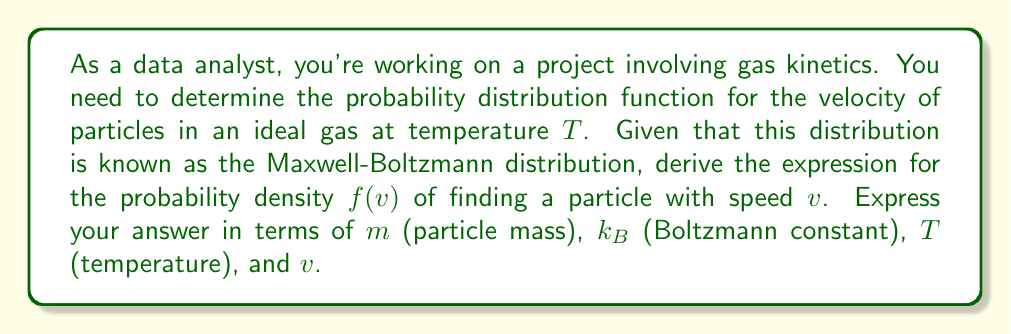Teach me how to tackle this problem. To derive the Maxwell-Boltzmann distribution, we'll follow these steps:

1) In three dimensions, the velocity distribution is given by:

   $$f(v_x, v_y, v_z) = A \exp\left(-\frac{m(v_x^2 + v_y^2 + v_z^2)}{2k_BT}\right)$$

   where $A$ is a normalization constant.

2) We want to find $f(v)$, where $v = \sqrt{v_x^2 + v_y^2 + v_z^2}$. To do this, we need to integrate over all directions in spherical coordinates.

3) In spherical coordinates, $v_x^2 + v_y^2 + v_z^2 = v^2$, and the volume element is $4\pi v^2 dv$.

4) Therefore, $f(v)$ is given by:

   $$f(v) = 4\pi v^2 \cdot A \exp\left(-\frac{mv^2}{2k_BT}\right)$$

5) To find $A$, we use the normalization condition:

   $$\int_0^\infty f(v) dv = 1$$

6) Solving this integral equation gives:

   $$A = \left(\frac{m}{2\pi k_BT}\right)^{3/2}$$

7) Substituting this back into our expression for $f(v)$:

   $$f(v) = 4\pi v^2 \cdot \left(\frac{m}{2\pi k_BT}\right)^{3/2} \exp\left(-\frac{mv^2}{2k_BT}\right)$$

8) Simplifying:

   $$f(v) = 4\pi \left(\frac{m}{2\pi k_BT}\right)^{3/2} v^2 \exp\left(-\frac{mv^2}{2k_BT}\right)$$

This is the Maxwell-Boltzmann distribution for particle speeds in an ideal gas.
Answer: $$f(v) = 4\pi \left(\frac{m}{2\pi k_BT}\right)^{3/2} v^2 \exp\left(-\frac{mv^2}{2k_BT}\right)$$ 